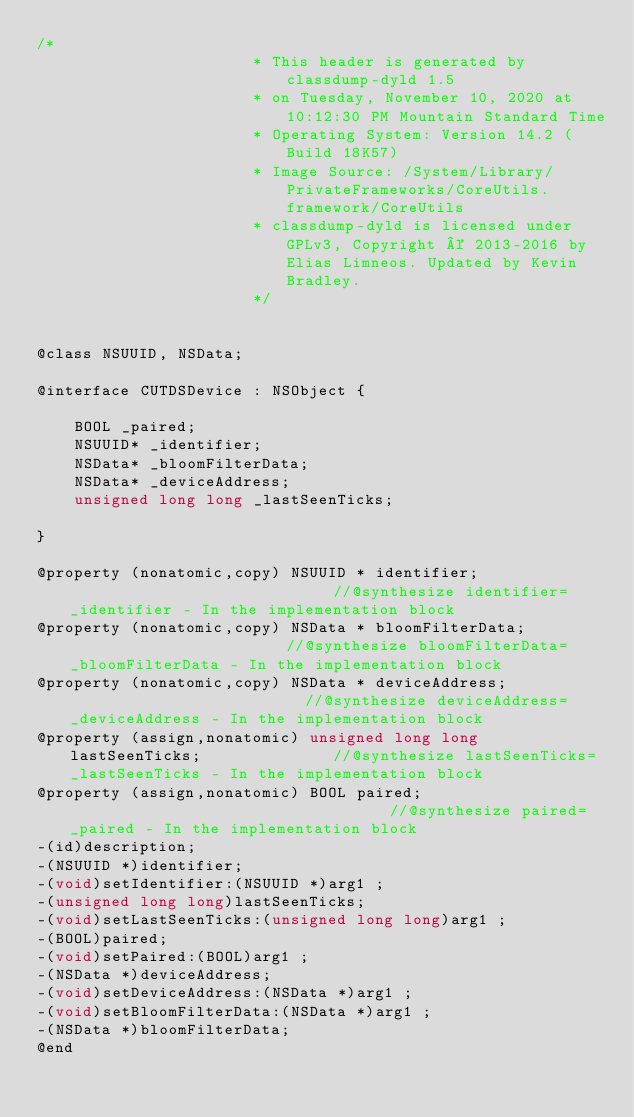Convert code to text. <code><loc_0><loc_0><loc_500><loc_500><_C_>/*
                       * This header is generated by classdump-dyld 1.5
                       * on Tuesday, November 10, 2020 at 10:12:30 PM Mountain Standard Time
                       * Operating System: Version 14.2 (Build 18K57)
                       * Image Source: /System/Library/PrivateFrameworks/CoreUtils.framework/CoreUtils
                       * classdump-dyld is licensed under GPLv3, Copyright © 2013-2016 by Elias Limneos. Updated by Kevin Bradley.
                       */


@class NSUUID, NSData;

@interface CUTDSDevice : NSObject {

	BOOL _paired;
	NSUUID* _identifier;
	NSData* _bloomFilterData;
	NSData* _deviceAddress;
	unsigned long long _lastSeenTicks;

}

@property (nonatomic,copy) NSUUID * identifier;                             //@synthesize identifier=_identifier - In the implementation block
@property (nonatomic,copy) NSData * bloomFilterData;                        //@synthesize bloomFilterData=_bloomFilterData - In the implementation block
@property (nonatomic,copy) NSData * deviceAddress;                          //@synthesize deviceAddress=_deviceAddress - In the implementation block
@property (assign,nonatomic) unsigned long long lastSeenTicks;              //@synthesize lastSeenTicks=_lastSeenTicks - In the implementation block
@property (assign,nonatomic) BOOL paired;                                   //@synthesize paired=_paired - In the implementation block
-(id)description;
-(NSUUID *)identifier;
-(void)setIdentifier:(NSUUID *)arg1 ;
-(unsigned long long)lastSeenTicks;
-(void)setLastSeenTicks:(unsigned long long)arg1 ;
-(BOOL)paired;
-(void)setPaired:(BOOL)arg1 ;
-(NSData *)deviceAddress;
-(void)setDeviceAddress:(NSData *)arg1 ;
-(void)setBloomFilterData:(NSData *)arg1 ;
-(NSData *)bloomFilterData;
@end

</code> 